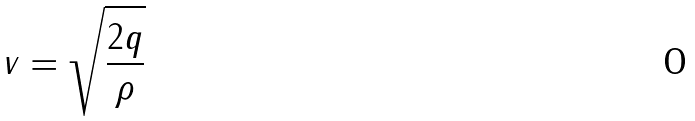Convert formula to latex. <formula><loc_0><loc_0><loc_500><loc_500>v = \sqrt { \frac { 2 q } { \rho } }</formula> 